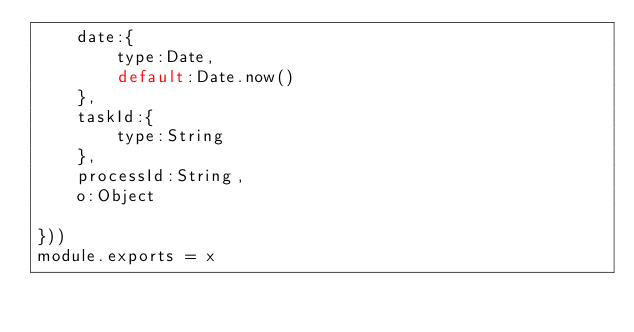<code> <loc_0><loc_0><loc_500><loc_500><_JavaScript_>	date:{
		type:Date,
		default:Date.now()
	},
	taskId:{
		type:String
	},
	processId:String,
	o:Object

}))
module.exports = x</code> 